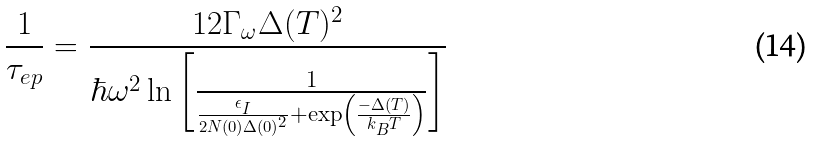<formula> <loc_0><loc_0><loc_500><loc_500>\frac { 1 } { \tau _ { e p } } = \frac { 1 2 \Gamma _ { \omega } \Delta ( T ) ^ { 2 } } { \hbar { \omega } ^ { 2 } \ln \left [ \frac { 1 } { \frac { \epsilon _ { I } } { 2 N ( 0 ) \Delta ( 0 ) ^ { 2 } } + \exp \left ( \frac { - \Delta ( T ) } { k _ { B } T } \right ) } \right ] }</formula> 